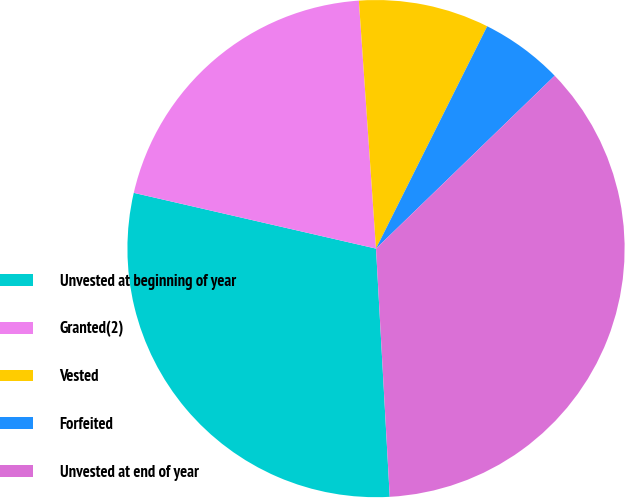Convert chart to OTSL. <chart><loc_0><loc_0><loc_500><loc_500><pie_chart><fcel>Unvested at beginning of year<fcel>Granted(2)<fcel>Vested<fcel>Forfeited<fcel>Unvested at end of year<nl><fcel>29.48%<fcel>20.3%<fcel>8.48%<fcel>5.38%<fcel>36.36%<nl></chart> 